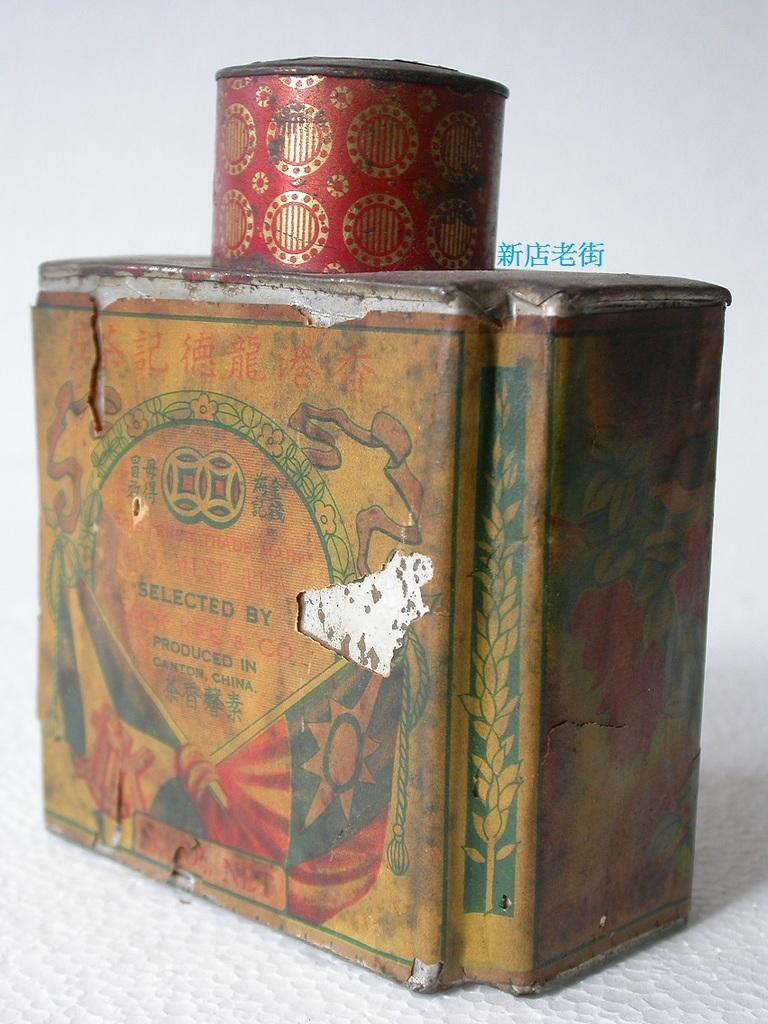<image>
Present a compact description of the photo's key features. an old colorful tin reading Selected By with a red tin on top 